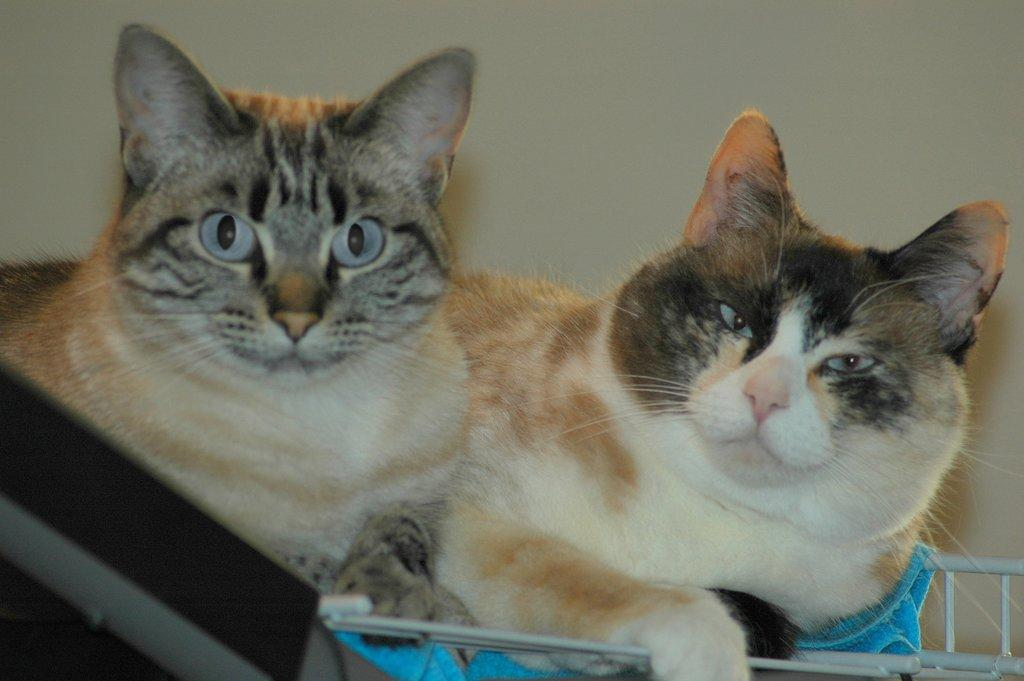What animals are in the foreground of the image? There are cats in the foreground of the image. What item can be seen in the image besides the cats? There is a towel in the image. What other objects are present at the bottom side of the image? There are other objects at the bottom side of the image, but their specific details are not mentioned in the provided facts. What type of cabbage is being used as a tax incentive in the image? There is no cabbage or tax incentive present in the image; it features cats and a towel. What brand of soda is being consumed by the cats in the image? There is no soda present in the image; it only shows cats and a towel. 